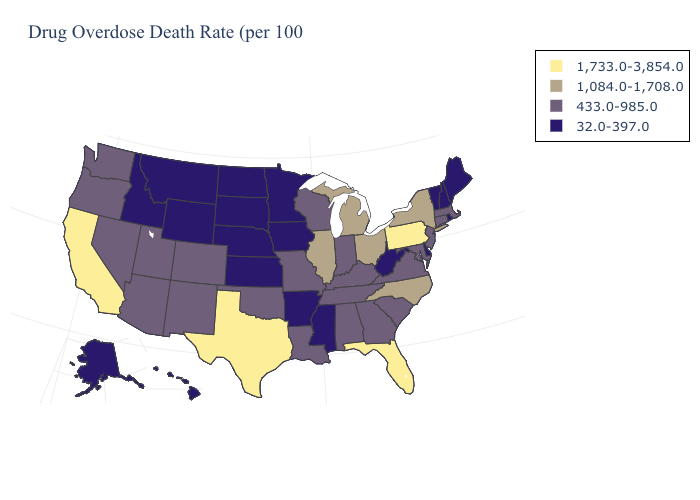What is the value of Ohio?
Concise answer only. 1,084.0-1,708.0. Name the states that have a value in the range 1,084.0-1,708.0?
Keep it brief. Illinois, Michigan, New York, North Carolina, Ohio. Does the first symbol in the legend represent the smallest category?
Write a very short answer. No. What is the highest value in the USA?
Answer briefly. 1,733.0-3,854.0. What is the lowest value in states that border Wyoming?
Keep it brief. 32.0-397.0. Does Florida have the highest value in the USA?
Answer briefly. Yes. What is the value of Ohio?
Concise answer only. 1,084.0-1,708.0. What is the value of North Dakota?
Write a very short answer. 32.0-397.0. What is the value of Washington?
Short answer required. 433.0-985.0. Is the legend a continuous bar?
Be succinct. No. Does Alaska have the highest value in the USA?
Be succinct. No. Among the states that border Arizona , does California have the lowest value?
Write a very short answer. No. Name the states that have a value in the range 1,084.0-1,708.0?
Concise answer only. Illinois, Michigan, New York, North Carolina, Ohio. Name the states that have a value in the range 433.0-985.0?
Write a very short answer. Alabama, Arizona, Colorado, Connecticut, Georgia, Indiana, Kentucky, Louisiana, Maryland, Massachusetts, Missouri, Nevada, New Jersey, New Mexico, Oklahoma, Oregon, South Carolina, Tennessee, Utah, Virginia, Washington, Wisconsin. Does New Mexico have a higher value than Alaska?
Short answer required. Yes. 